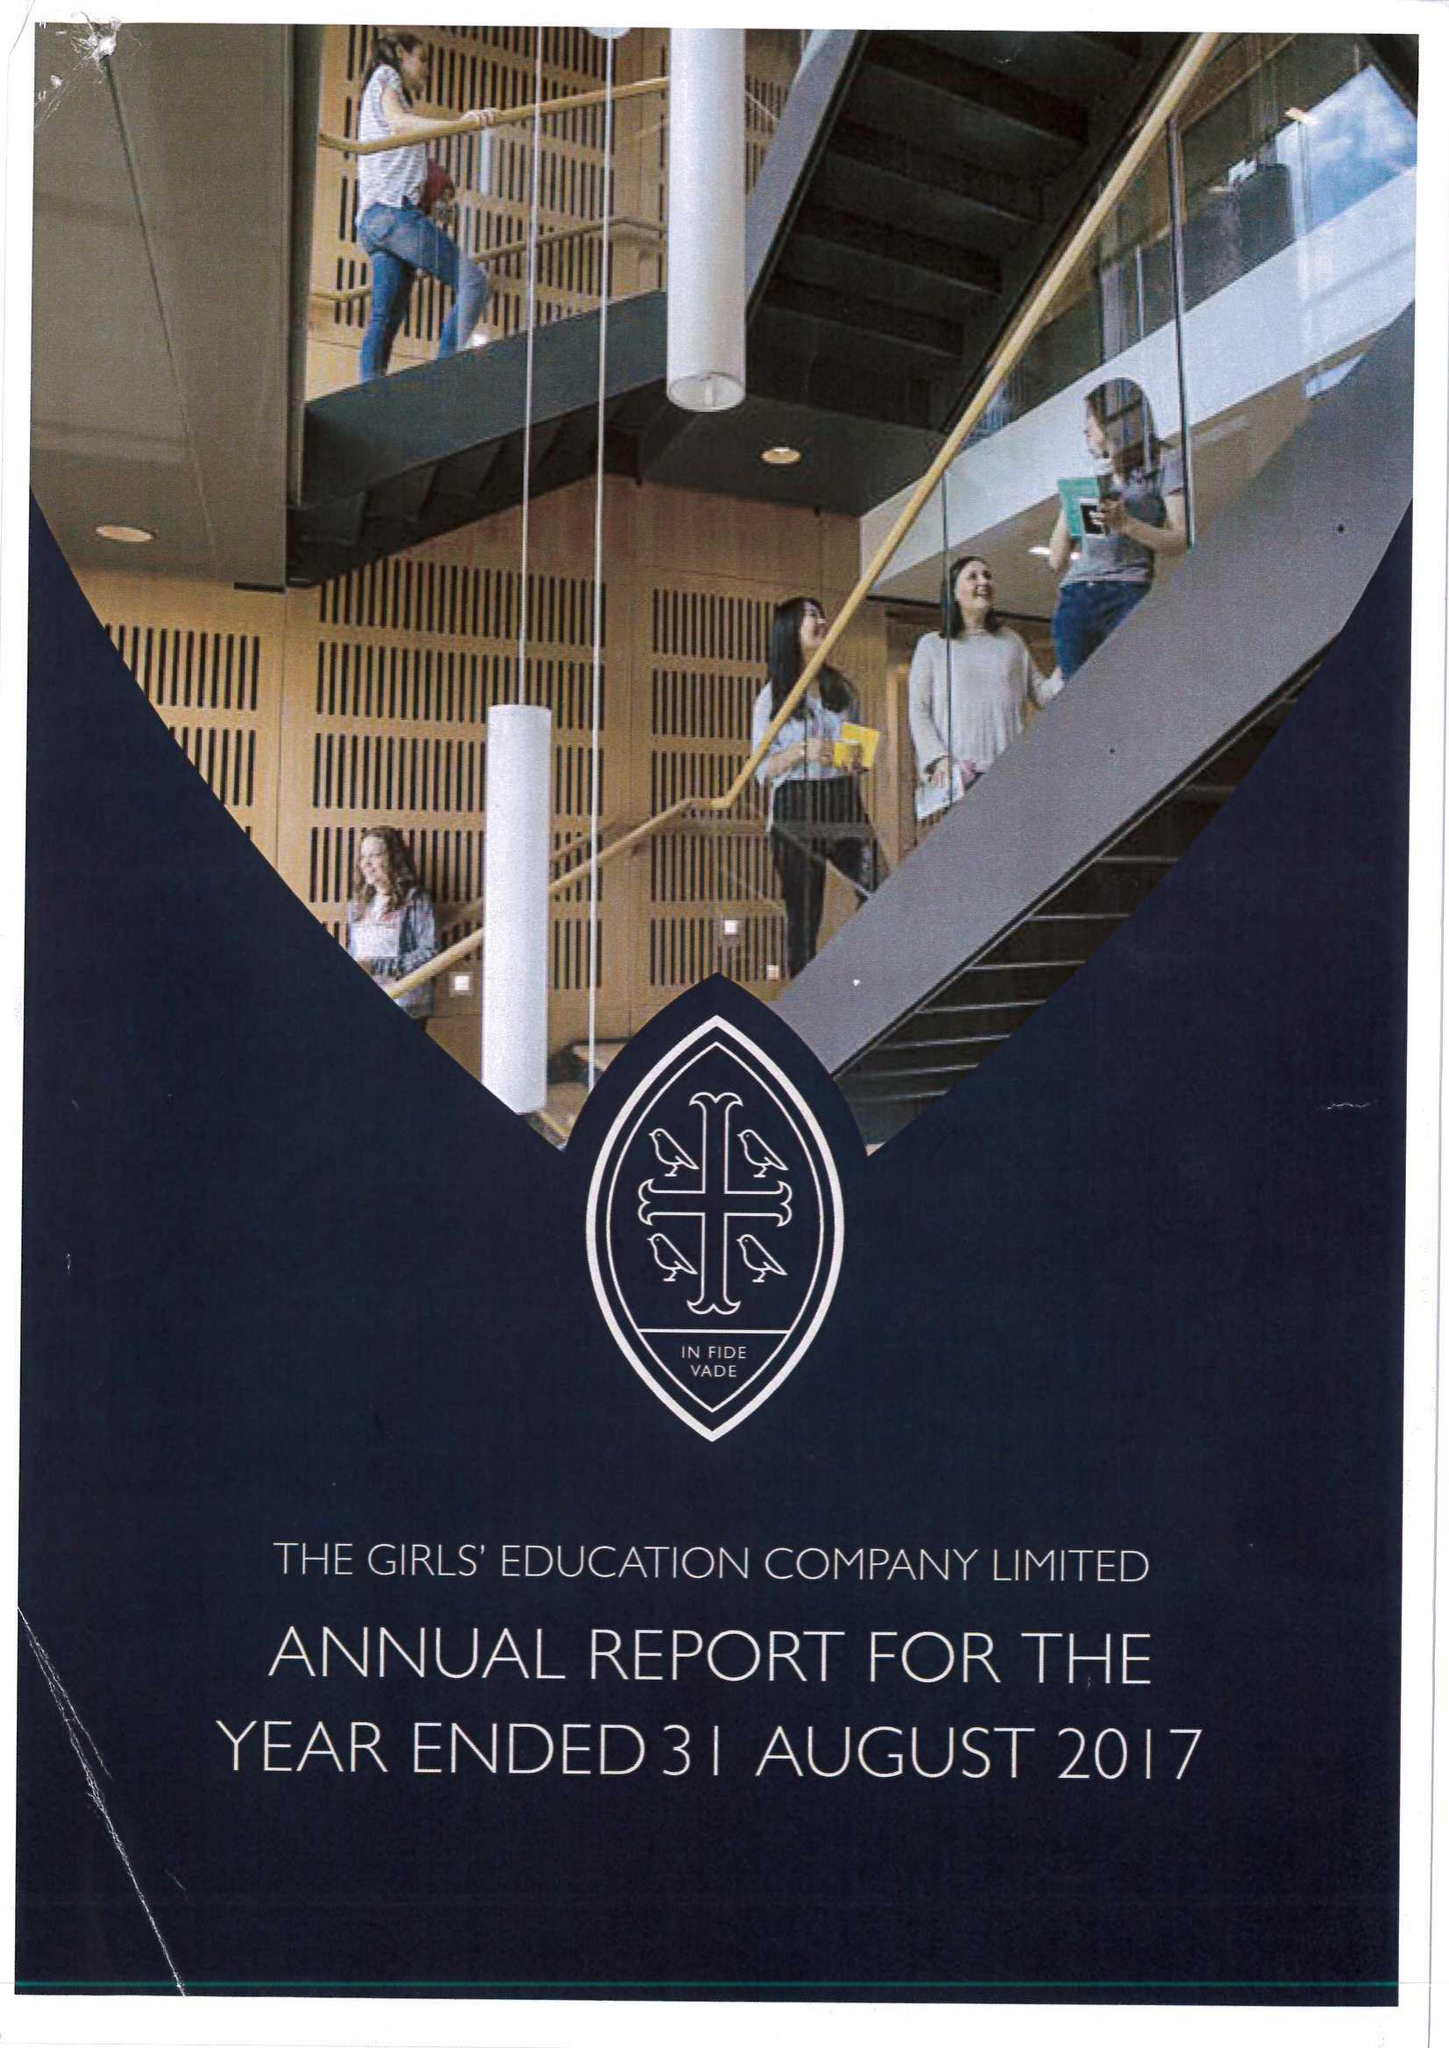What is the value for the address__postcode?
Answer the question using a single word or phrase. HP11 1PE 